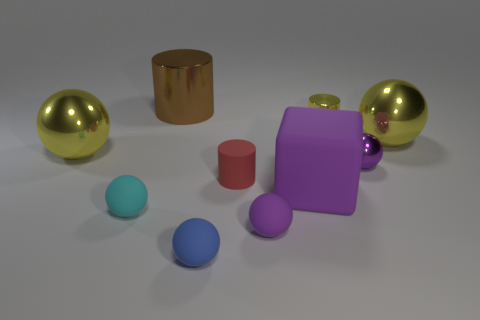Are there any other shiny things that have the same shape as the tiny red object?
Offer a terse response. Yes. What number of big brown things are there?
Provide a short and direct response. 1. Do the yellow ball on the left side of the brown metallic object and the purple block have the same material?
Ensure brevity in your answer.  No. Are there any matte balls that have the same size as the brown cylinder?
Provide a succinct answer. No. There is a brown metallic thing; is it the same shape as the tiny rubber thing behind the small cyan object?
Make the answer very short. Yes. Are there any yellow cylinders that are on the right side of the small metallic thing in front of the big shiny ball right of the big brown metallic cylinder?
Your answer should be compact. No. The blue object is what size?
Give a very brief answer. Small. How many other objects are there of the same color as the large cube?
Keep it short and to the point. 2. Is the shape of the small purple thing behind the red rubber cylinder the same as  the small yellow metallic object?
Keep it short and to the point. No. The other big object that is the same shape as the red matte thing is what color?
Your answer should be compact. Brown. 